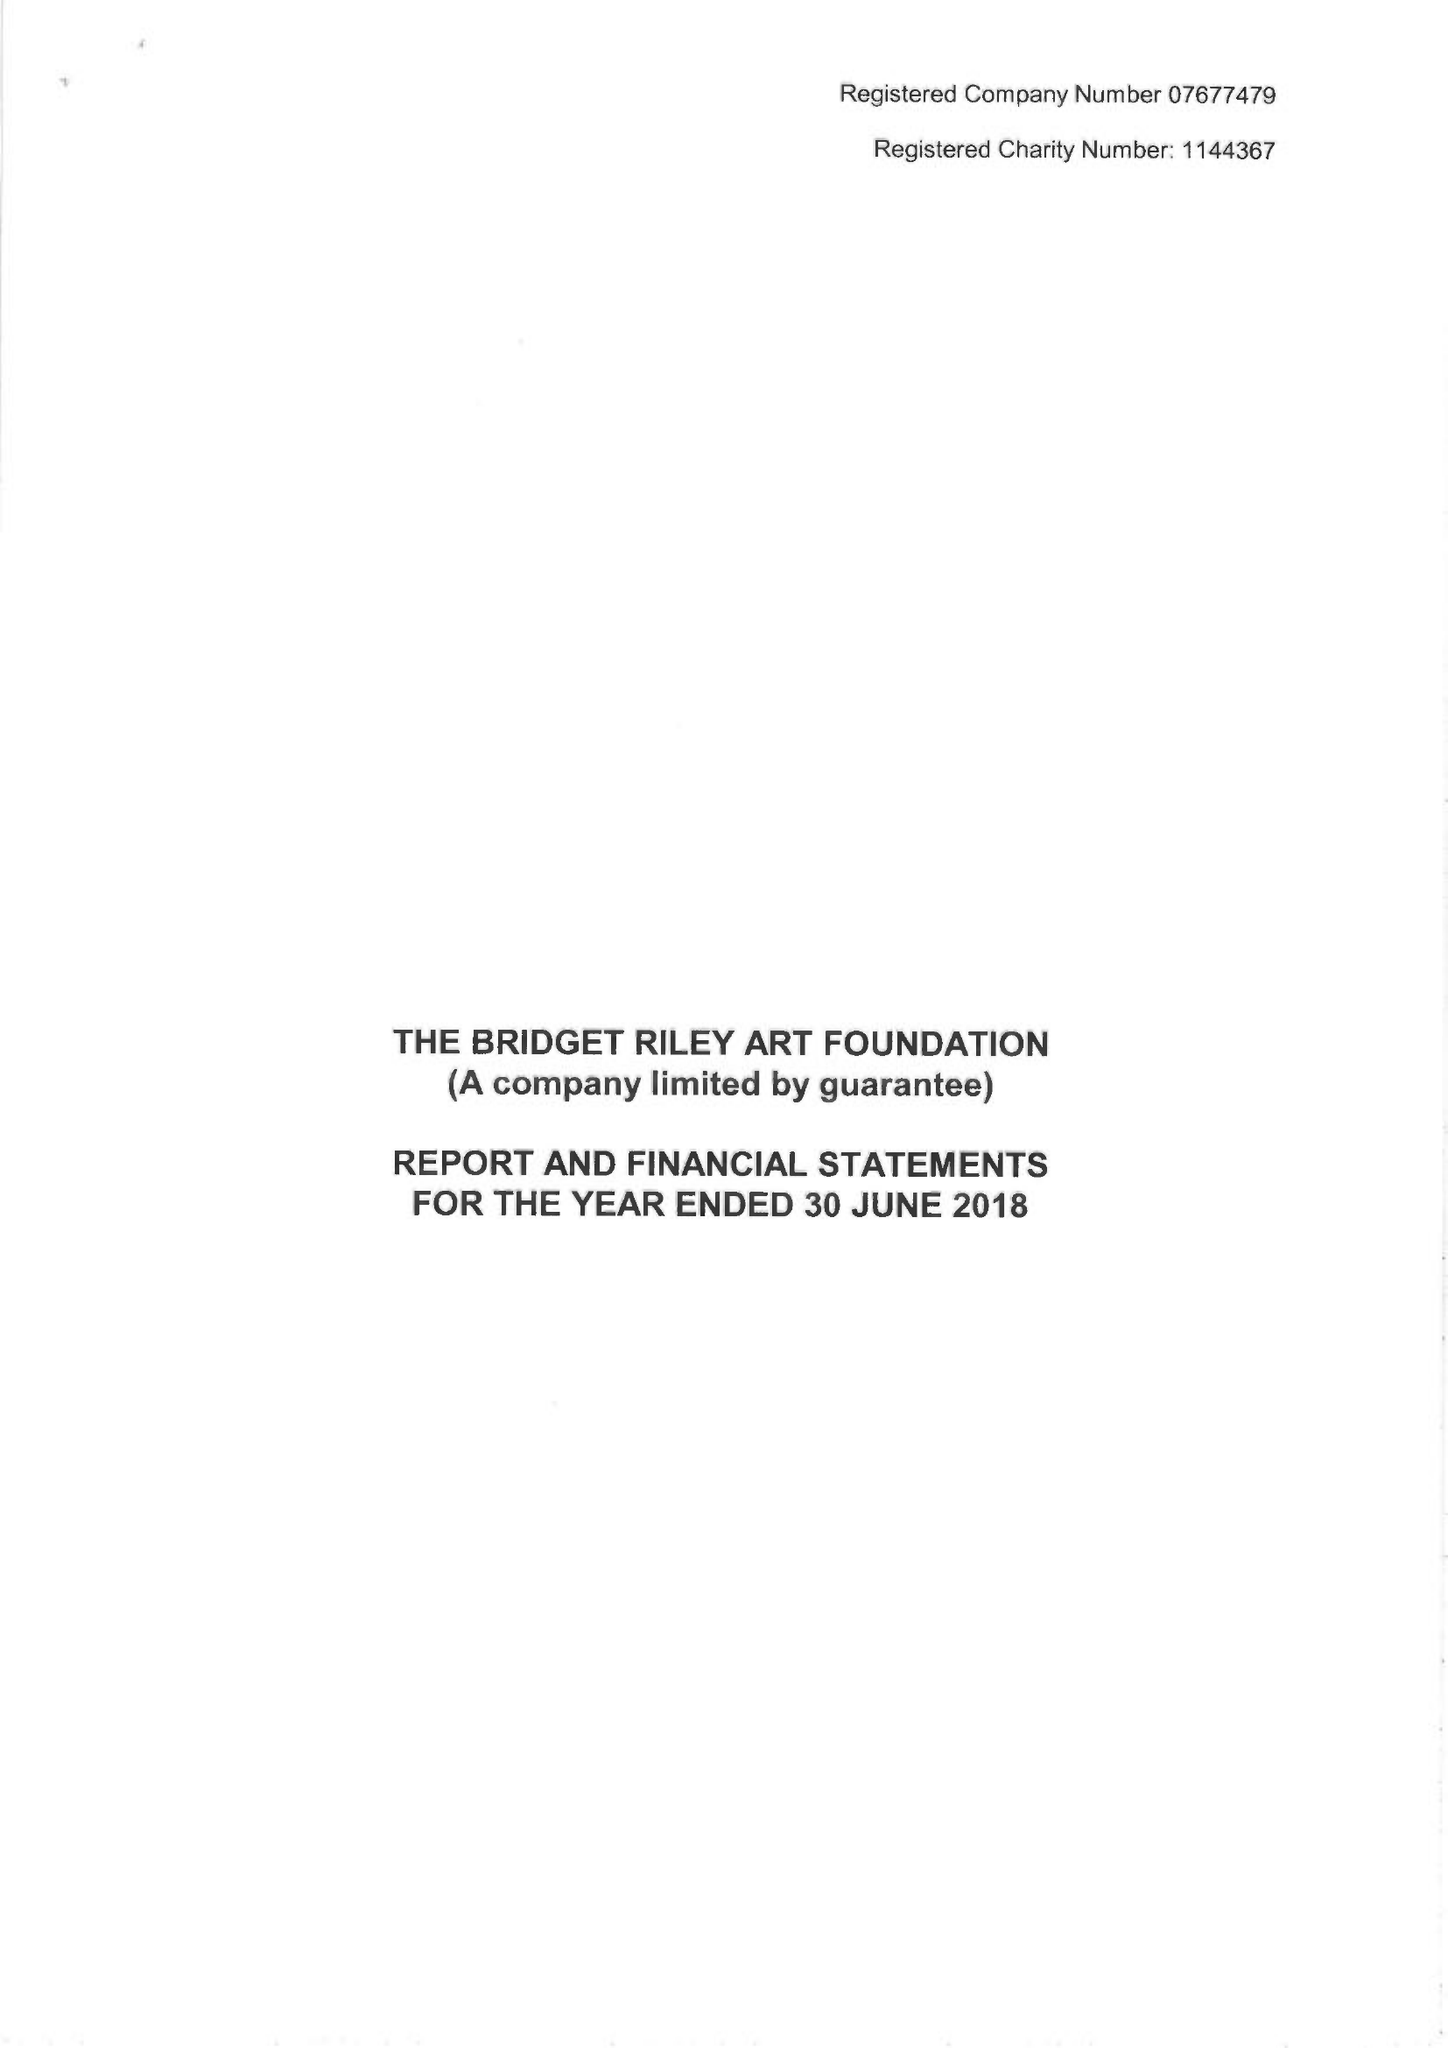What is the value for the charity_name?
Answer the question using a single word or phrase. The Bridget Riley Art Foundation 